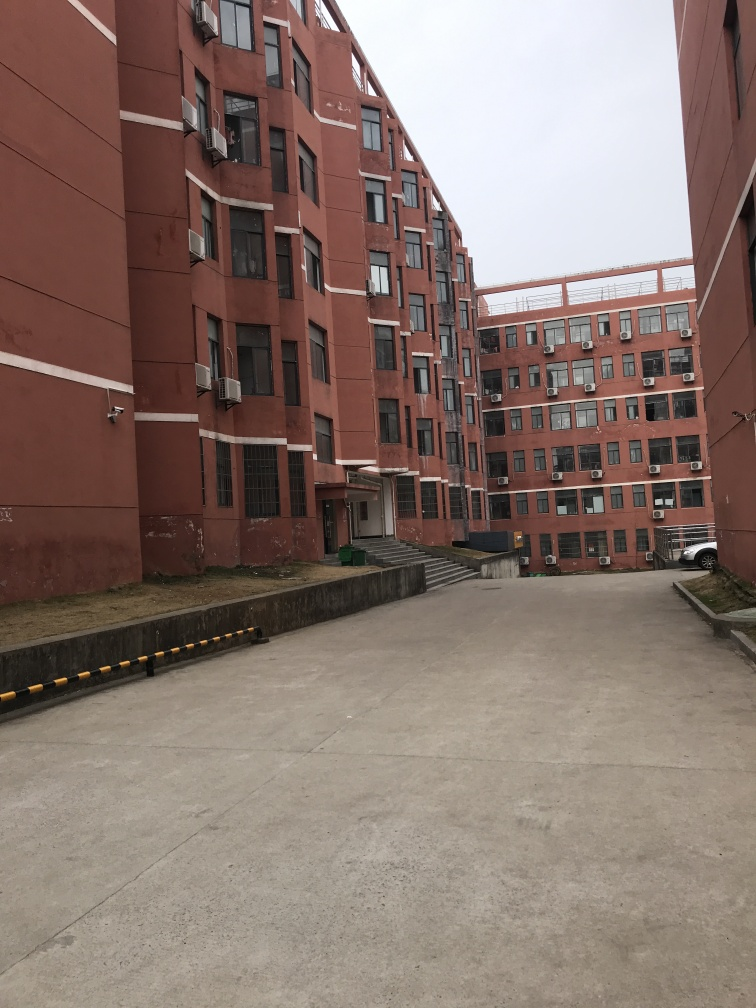What is the quality of this image? The quality of the image can be considered average; it is not poor since the details are relatively clear, it's well-lit and there's no significant blurring. However, it's also not notably high-quality due to the lack of sharpness and the composition that leaves ample unused space, which could have been better utilized to capture more compelling elements of the scene. 